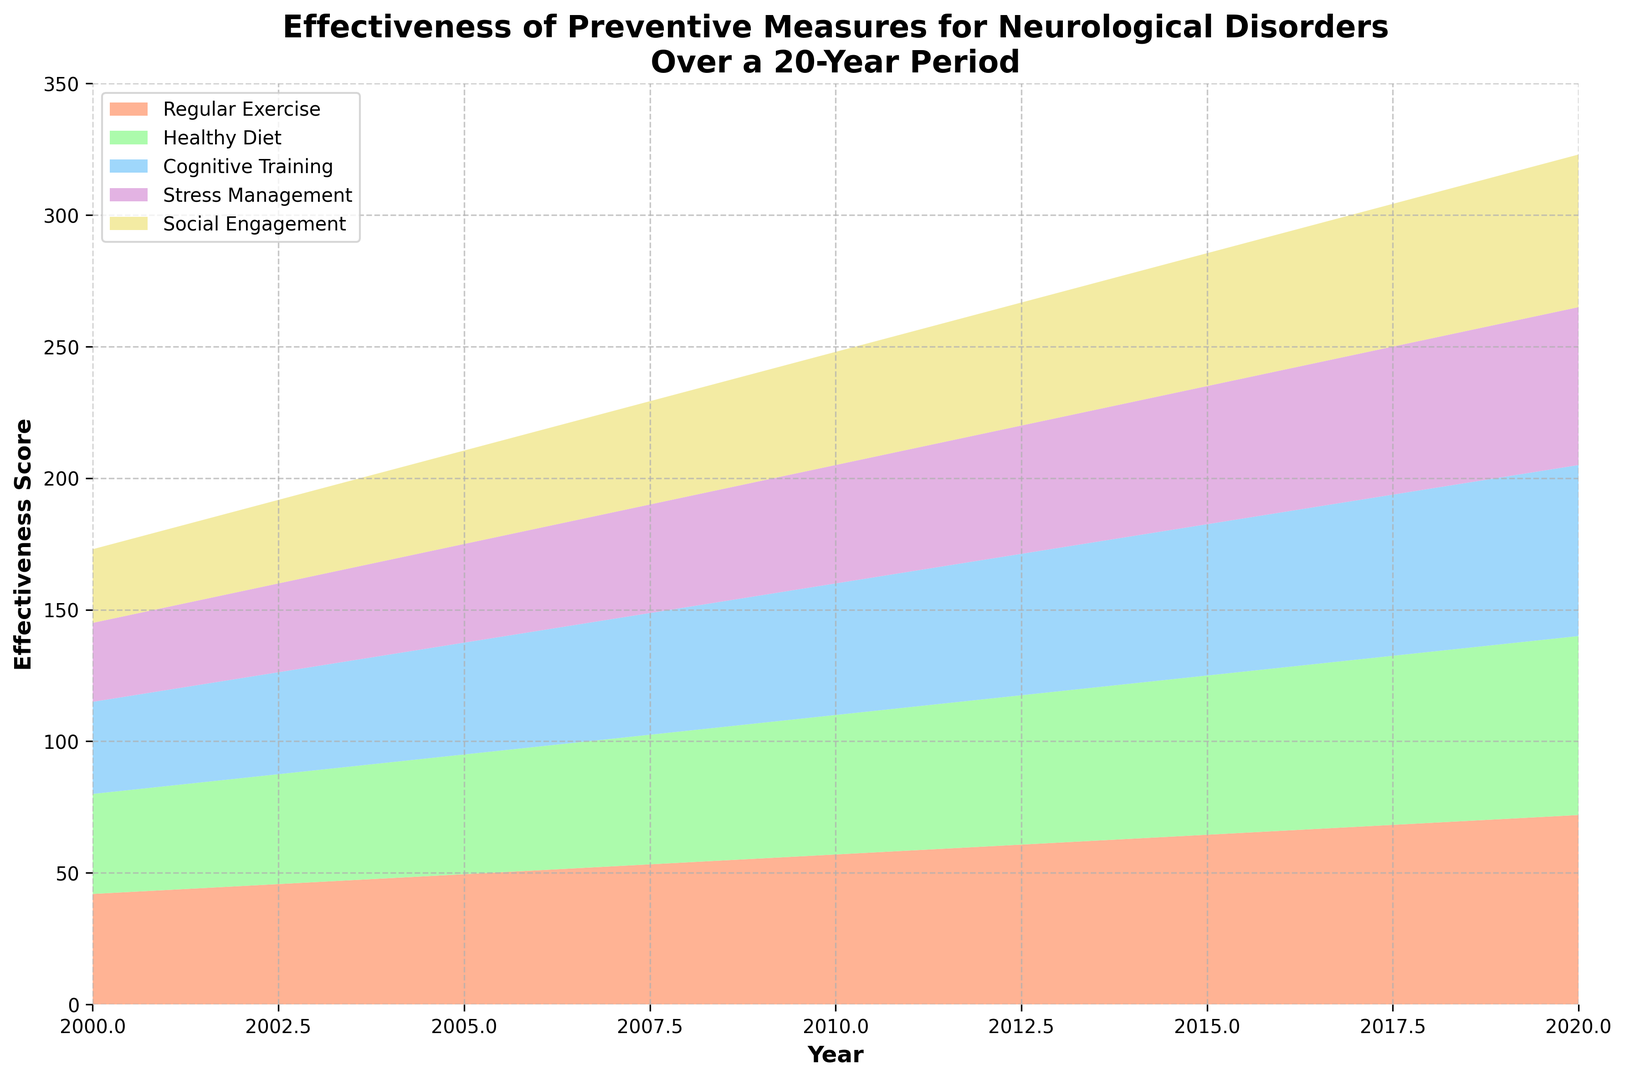What is the effectiveness score of Stress Management in 2012? Locate the year 2012 on the x-axis and find the effectiveness score for Stress Management, which should be visually represented with one of the colors. Check the corresponding height on the y-axis.
Answer: 48 Which preventive measure showed the highest effectiveness in 2014? In 2014, observe all the colored areas and identify the one with the greatest height or coverage in that year. Cross-reference with the legend to identify the corresponding measure.
Answer: Regular Exercise How did the effectiveness of Cognitive Training change from 2006 to 2020? Identify the heights corresponding to Cognitive Training in 2006 and 2020. Subtract the 2006 score from the 2020 score to determine the change.
Answer: Increased by 21 Which measure had the smallest increase in effectiveness over the 20 years? For each measure, find the difference between its effectiveness score in 2000 and 2020. Compare the differences to find the smallest one.
Answer: Social Engagement What are the total effectiveness scores for all measures combined in 2018? For 2018, sum the effectiveness scores of all five preventive measures. That is, 69 (Regular Exercise) + 65 (Healthy Diet) + 62 (Cognitive Training) + 57 (Stress Management) + 55 (Social Engagement).
Answer: 308 What is the average effectiveness score of Healthy Diet over the observed period? Add up the effectiveness scores of Healthy Diet across all the listed years and divide by the number of years (11). ((38+41+44+47+50+53+56+59+62+65+68) / 11).
Answer: 53.5 Which preventive measure showed a steeper increase between 2000 and 2008, Healthy Diet or Cognitive Training? Calculate the differences in effectiveness scores for Healthy Diet and Cognitive Training from 2000 to 2008. Compare which difference is greater.
Answer: Cognitive Training By how much did the effectiveness of Social Engagement increase from 2000 to 2010? Find the effectiveness scores for Social Engagement in 2000 and 2010. Subtract the 2000 value from the 2010 value.
Answer: Increased by 15 What is the trend in effectiveness for Regular Exercise over the 20-year period? Observe the change in the effectiveness scores of Regular Exercise from 2000 to 2020. Note the overall direction and whether it consistently increased, decreased, or fluctuated.
Answer: Consistently increased What are the combined effectiveness scores of Stress Management and Social Engagement in 2006? Add the effectiveness scores for Stress Management and Social Engagement for the year 2006. (39 + 37).
Answer: 76 